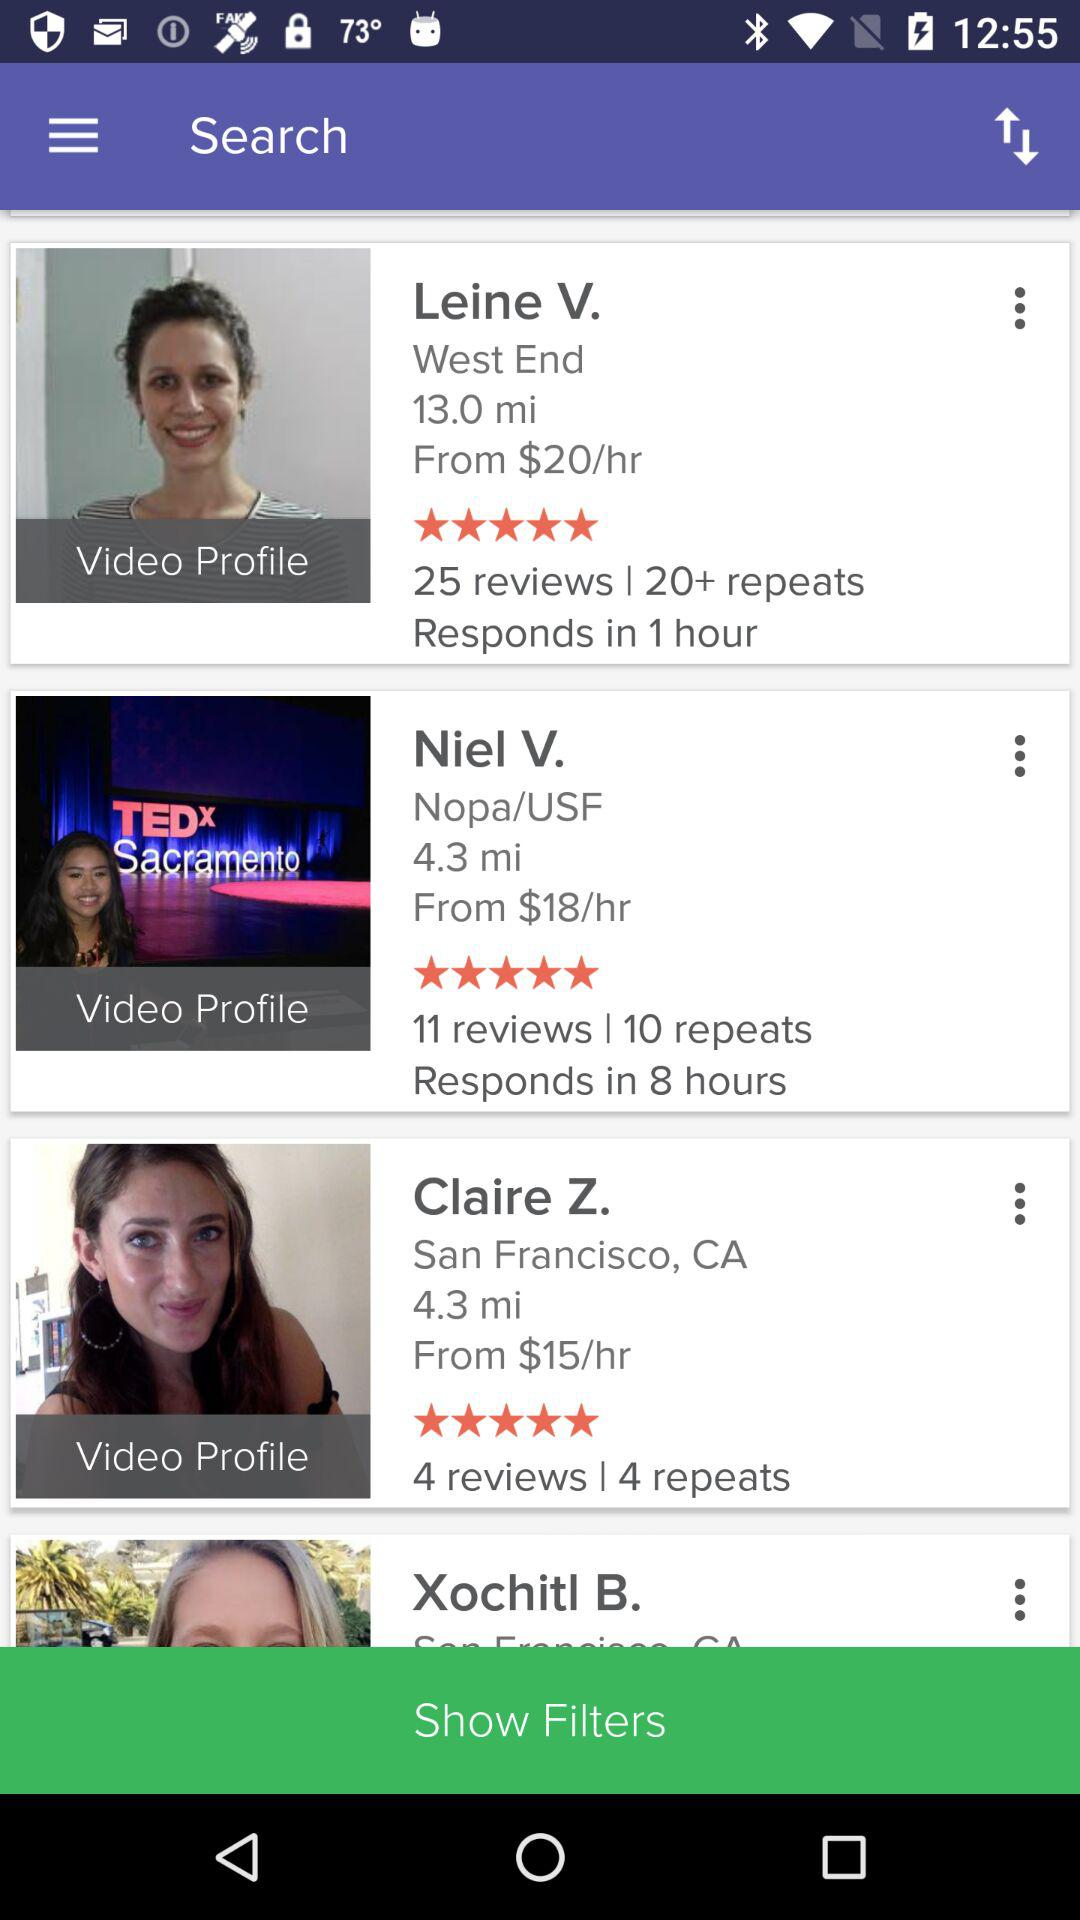What is the location of Claire Z.? The location of Claire Z. is San Francisco, CA. 